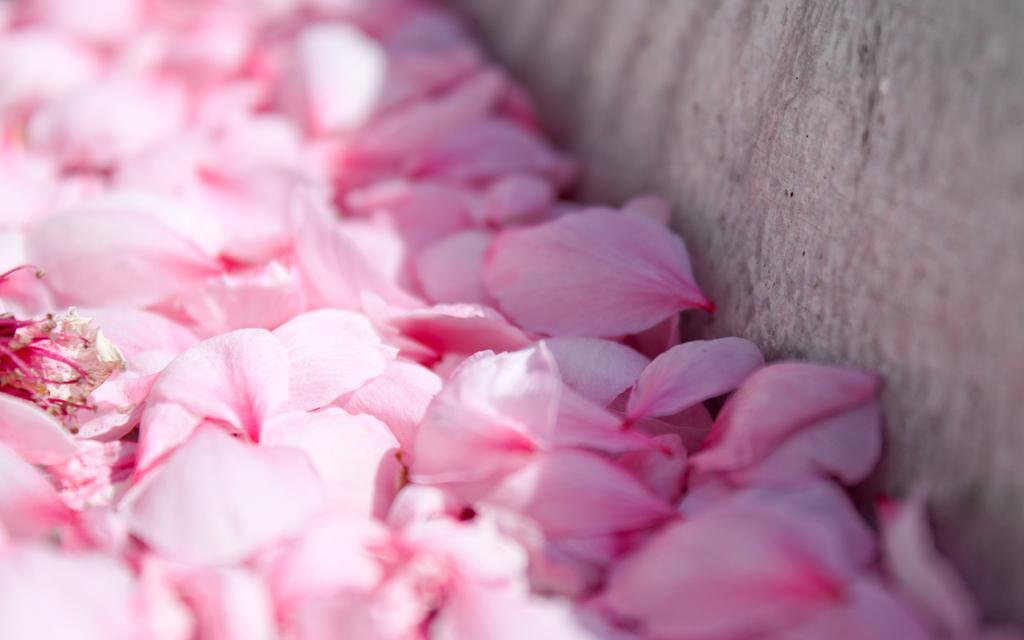How would you summarize this image in a sentence or two? In this image we can see few pink color petals and also we can see the wall. 